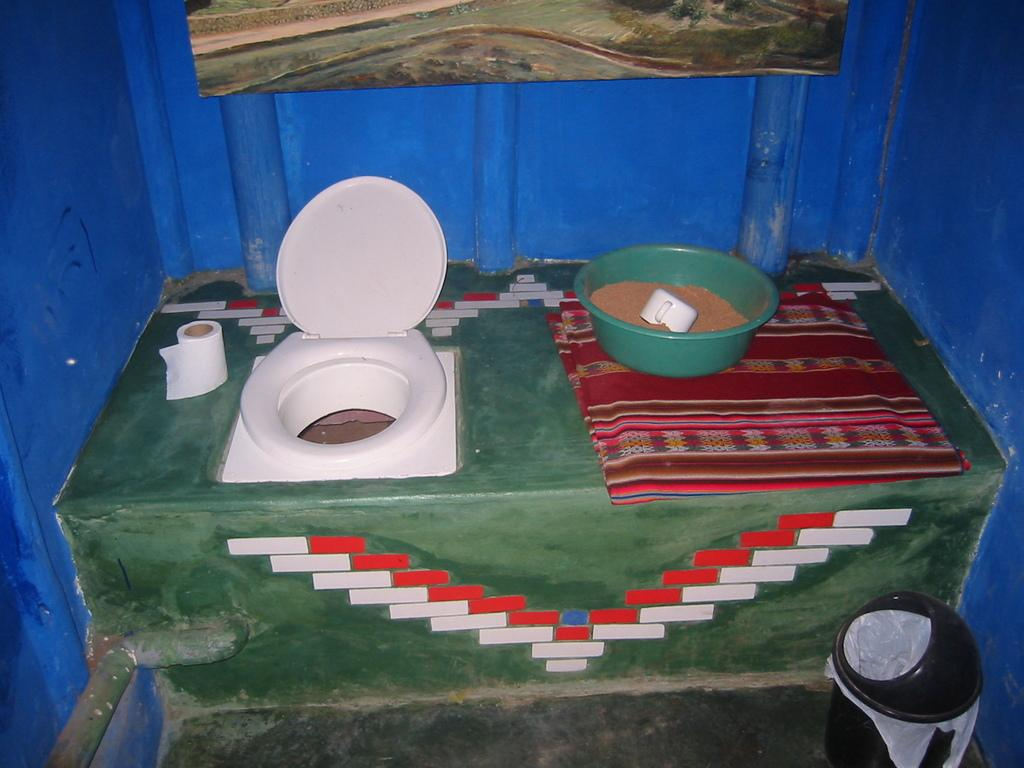What type of container is present in the image? There is a dustbin in the image. What is another object that can be seen in the image? There is a cup in the image. What is inside the tub in the image? There is sand in a tub in the image. What is the purpose of the toilet seat in the image? The toilet seat is present in the image. What item is used for wiping in the image? There is a paper roll in the image. What is attached to the wall in the image? There is a frame attached to the wall in the image. What type of fly can be seen buzzing around the dustbin in the image? There is no fly present in the image. What season is depicted in the image? The image does not depict a specific season; it only shows the objects mentioned in the facts. 